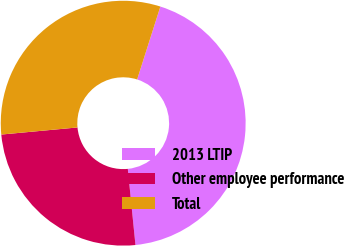Convert chart to OTSL. <chart><loc_0><loc_0><loc_500><loc_500><pie_chart><fcel>2013 LTIP<fcel>Other employee performance<fcel>Total<nl><fcel>43.5%<fcel>25.12%<fcel>31.39%<nl></chart> 